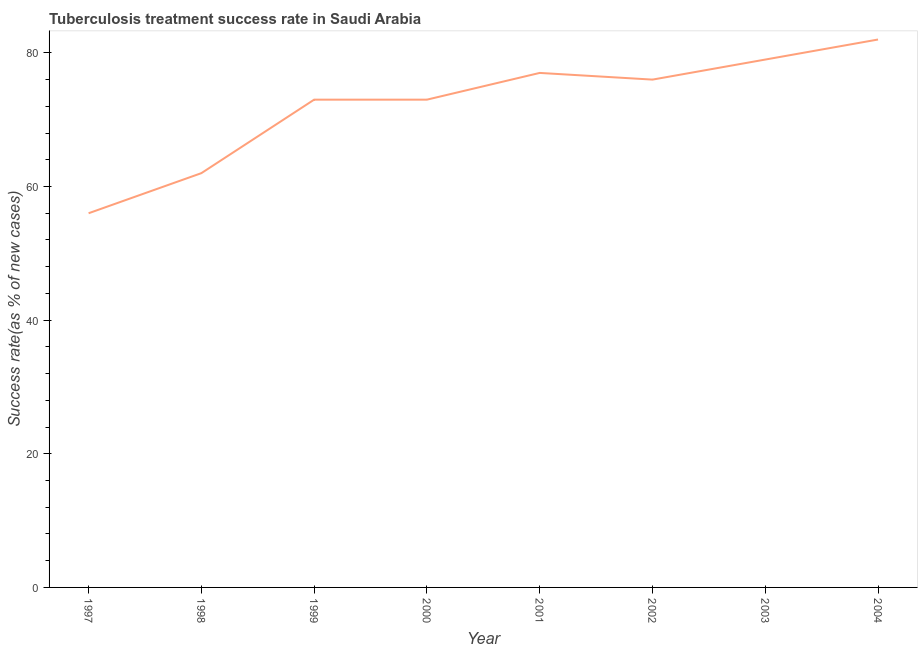What is the tuberculosis treatment success rate in 2004?
Offer a very short reply. 82. Across all years, what is the maximum tuberculosis treatment success rate?
Your response must be concise. 82. Across all years, what is the minimum tuberculosis treatment success rate?
Your answer should be very brief. 56. In which year was the tuberculosis treatment success rate maximum?
Your answer should be compact. 2004. What is the sum of the tuberculosis treatment success rate?
Your answer should be compact. 578. What is the difference between the tuberculosis treatment success rate in 1998 and 2004?
Your answer should be compact. -20. What is the average tuberculosis treatment success rate per year?
Your answer should be very brief. 72.25. What is the median tuberculosis treatment success rate?
Ensure brevity in your answer.  74.5. In how many years, is the tuberculosis treatment success rate greater than 56 %?
Provide a short and direct response. 7. What is the ratio of the tuberculosis treatment success rate in 1998 to that in 2002?
Offer a terse response. 0.82. Is the tuberculosis treatment success rate in 1999 less than that in 2003?
Your response must be concise. Yes. What is the difference between the highest and the second highest tuberculosis treatment success rate?
Your answer should be compact. 3. What is the difference between the highest and the lowest tuberculosis treatment success rate?
Keep it short and to the point. 26. In how many years, is the tuberculosis treatment success rate greater than the average tuberculosis treatment success rate taken over all years?
Offer a terse response. 6. What is the title of the graph?
Give a very brief answer. Tuberculosis treatment success rate in Saudi Arabia. What is the label or title of the Y-axis?
Your answer should be compact. Success rate(as % of new cases). What is the Success rate(as % of new cases) in 1997?
Keep it short and to the point. 56. What is the Success rate(as % of new cases) of 1998?
Make the answer very short. 62. What is the Success rate(as % of new cases) in 1999?
Your response must be concise. 73. What is the Success rate(as % of new cases) of 2000?
Keep it short and to the point. 73. What is the Success rate(as % of new cases) of 2001?
Your answer should be compact. 77. What is the Success rate(as % of new cases) in 2003?
Offer a very short reply. 79. What is the difference between the Success rate(as % of new cases) in 1997 and 1998?
Ensure brevity in your answer.  -6. What is the difference between the Success rate(as % of new cases) in 1997 and 1999?
Your answer should be compact. -17. What is the difference between the Success rate(as % of new cases) in 1997 and 2002?
Offer a terse response. -20. What is the difference between the Success rate(as % of new cases) in 1997 and 2003?
Provide a succinct answer. -23. What is the difference between the Success rate(as % of new cases) in 1998 and 1999?
Provide a short and direct response. -11. What is the difference between the Success rate(as % of new cases) in 1998 and 2003?
Provide a succinct answer. -17. What is the difference between the Success rate(as % of new cases) in 1999 and 2000?
Your answer should be very brief. 0. What is the difference between the Success rate(as % of new cases) in 1999 and 2001?
Keep it short and to the point. -4. What is the difference between the Success rate(as % of new cases) in 1999 and 2002?
Your answer should be compact. -3. What is the difference between the Success rate(as % of new cases) in 1999 and 2004?
Keep it short and to the point. -9. What is the difference between the Success rate(as % of new cases) in 2000 and 2001?
Your answer should be very brief. -4. What is the difference between the Success rate(as % of new cases) in 2000 and 2003?
Your answer should be very brief. -6. What is the difference between the Success rate(as % of new cases) in 2000 and 2004?
Give a very brief answer. -9. What is the difference between the Success rate(as % of new cases) in 2001 and 2004?
Offer a terse response. -5. What is the ratio of the Success rate(as % of new cases) in 1997 to that in 1998?
Make the answer very short. 0.9. What is the ratio of the Success rate(as % of new cases) in 1997 to that in 1999?
Make the answer very short. 0.77. What is the ratio of the Success rate(as % of new cases) in 1997 to that in 2000?
Ensure brevity in your answer.  0.77. What is the ratio of the Success rate(as % of new cases) in 1997 to that in 2001?
Your answer should be compact. 0.73. What is the ratio of the Success rate(as % of new cases) in 1997 to that in 2002?
Provide a short and direct response. 0.74. What is the ratio of the Success rate(as % of new cases) in 1997 to that in 2003?
Ensure brevity in your answer.  0.71. What is the ratio of the Success rate(as % of new cases) in 1997 to that in 2004?
Make the answer very short. 0.68. What is the ratio of the Success rate(as % of new cases) in 1998 to that in 1999?
Your answer should be compact. 0.85. What is the ratio of the Success rate(as % of new cases) in 1998 to that in 2000?
Your answer should be compact. 0.85. What is the ratio of the Success rate(as % of new cases) in 1998 to that in 2001?
Offer a very short reply. 0.81. What is the ratio of the Success rate(as % of new cases) in 1998 to that in 2002?
Keep it short and to the point. 0.82. What is the ratio of the Success rate(as % of new cases) in 1998 to that in 2003?
Keep it short and to the point. 0.79. What is the ratio of the Success rate(as % of new cases) in 1998 to that in 2004?
Your answer should be very brief. 0.76. What is the ratio of the Success rate(as % of new cases) in 1999 to that in 2000?
Offer a very short reply. 1. What is the ratio of the Success rate(as % of new cases) in 1999 to that in 2001?
Provide a succinct answer. 0.95. What is the ratio of the Success rate(as % of new cases) in 1999 to that in 2003?
Make the answer very short. 0.92. What is the ratio of the Success rate(as % of new cases) in 1999 to that in 2004?
Your answer should be compact. 0.89. What is the ratio of the Success rate(as % of new cases) in 2000 to that in 2001?
Keep it short and to the point. 0.95. What is the ratio of the Success rate(as % of new cases) in 2000 to that in 2003?
Your answer should be very brief. 0.92. What is the ratio of the Success rate(as % of new cases) in 2000 to that in 2004?
Your answer should be compact. 0.89. What is the ratio of the Success rate(as % of new cases) in 2001 to that in 2002?
Your answer should be very brief. 1.01. What is the ratio of the Success rate(as % of new cases) in 2001 to that in 2003?
Provide a short and direct response. 0.97. What is the ratio of the Success rate(as % of new cases) in 2001 to that in 2004?
Your answer should be very brief. 0.94. What is the ratio of the Success rate(as % of new cases) in 2002 to that in 2003?
Provide a short and direct response. 0.96. What is the ratio of the Success rate(as % of new cases) in 2002 to that in 2004?
Provide a short and direct response. 0.93. 